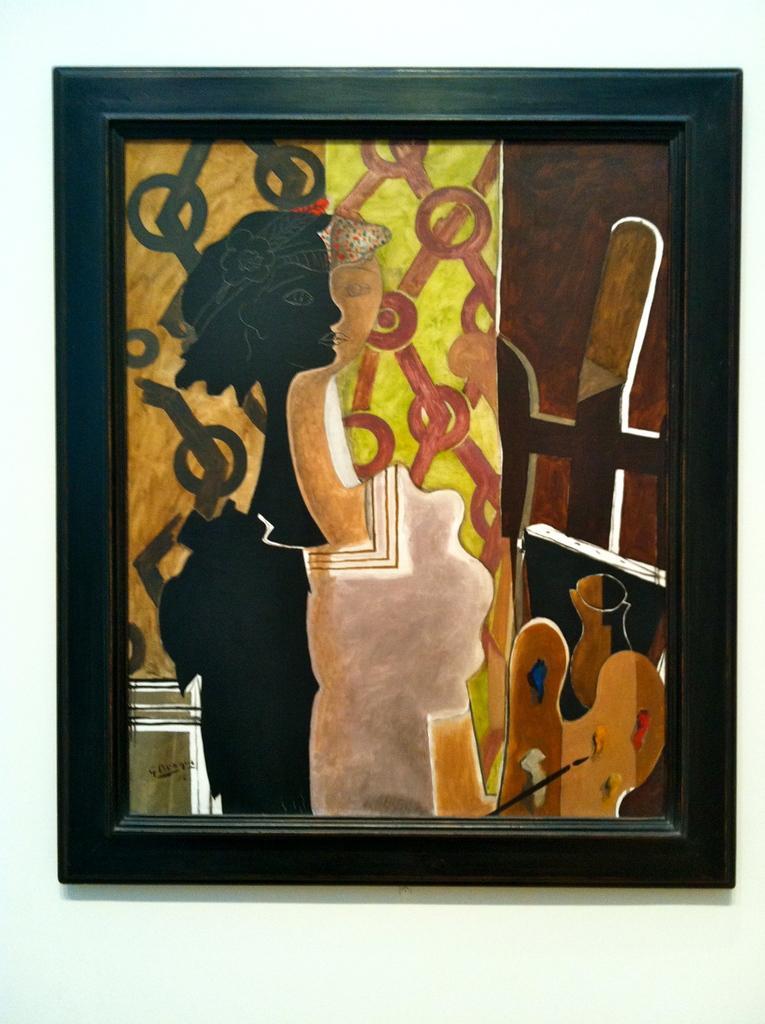Can you describe this image briefly? In this image, we can see a painting with frame on the white surface. 